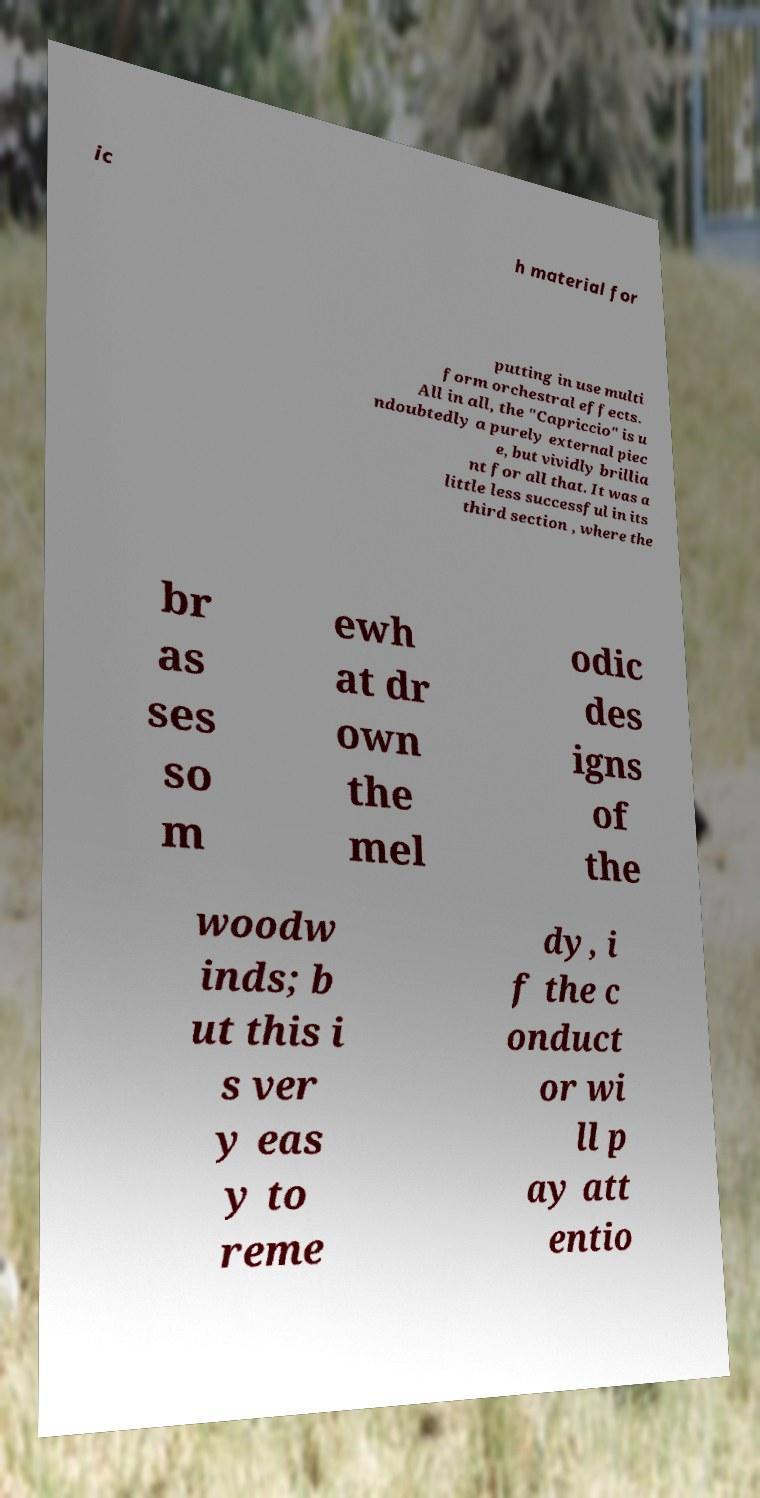Can you read and provide the text displayed in the image?This photo seems to have some interesting text. Can you extract and type it out for me? ic h material for putting in use multi form orchestral effects. All in all, the "Capriccio" is u ndoubtedly a purely external piec e, but vividly brillia nt for all that. It was a little less successful in its third section , where the br as ses so m ewh at dr own the mel odic des igns of the woodw inds; b ut this i s ver y eas y to reme dy, i f the c onduct or wi ll p ay att entio 